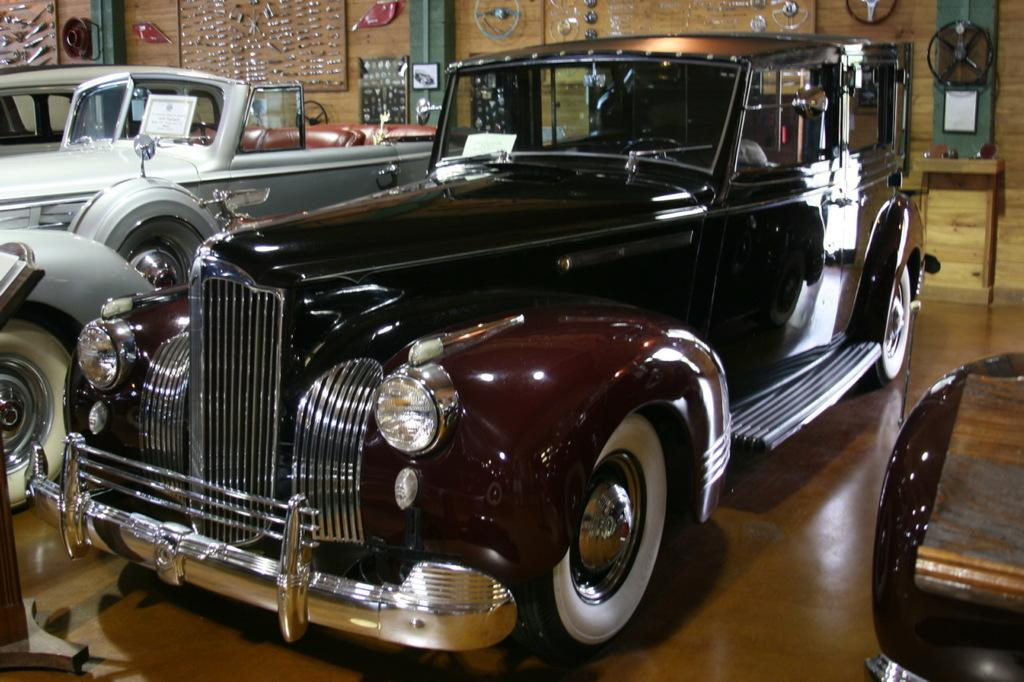What type of vehicles can be seen in the image? There are cars parked in the image. Where are the cars located? The cars are parked on the floor. What can be seen in the background of the image? There are steering wheels visible in the background of the image. What tools are visible on the wall in the background of the image? There are wrenches visible on the wall in the background of the image. What type of knife is being used to prepare the meal in the image? There is no knife or meal present in the image; it features parked cars and tools on the wall. 